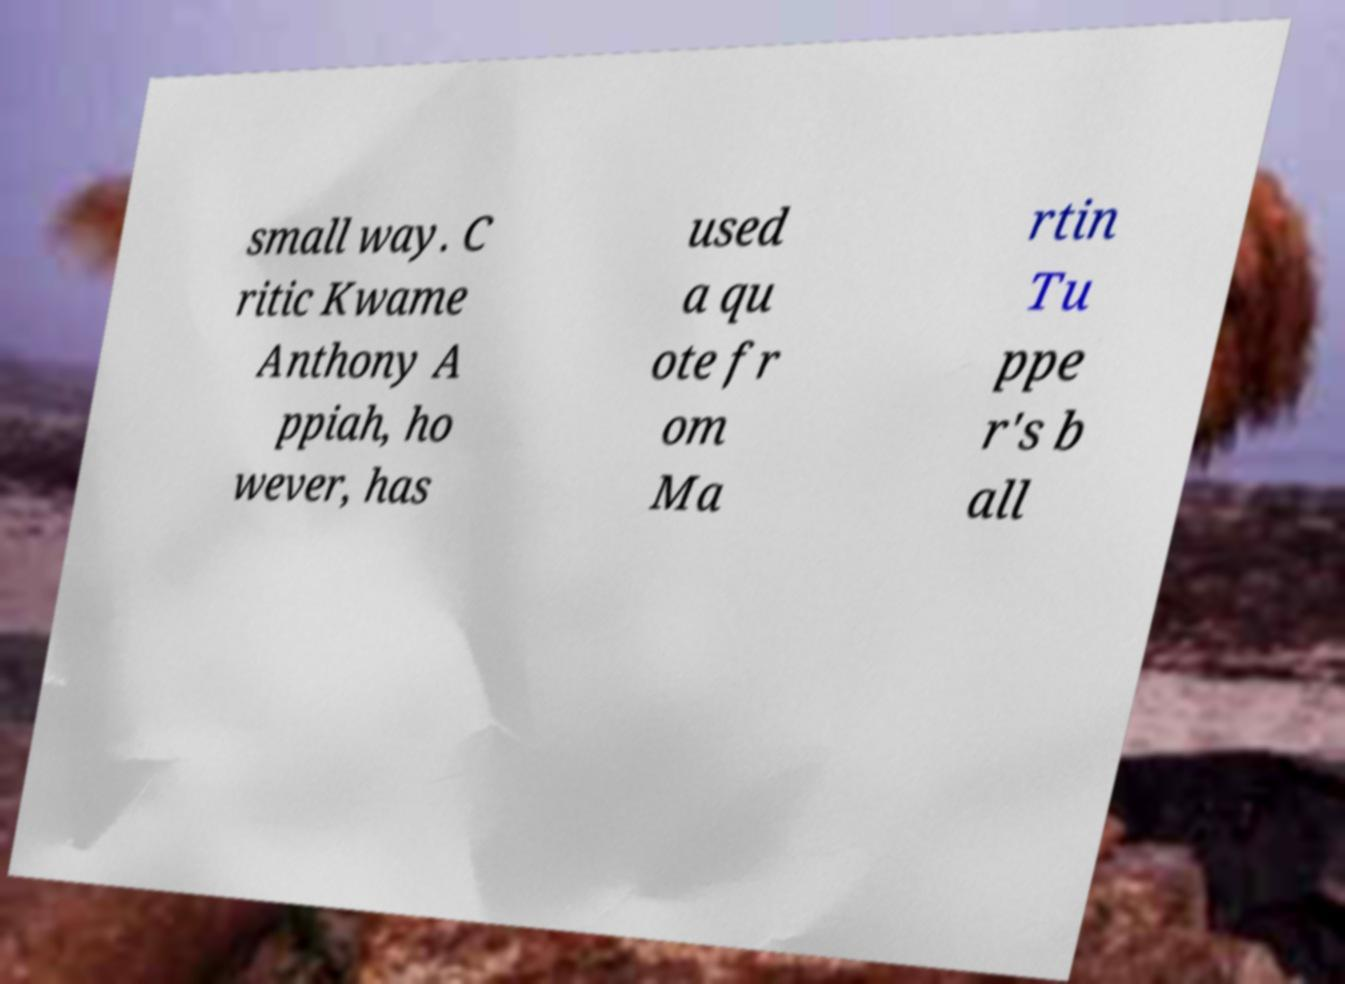What messages or text are displayed in this image? I need them in a readable, typed format. small way. C ritic Kwame Anthony A ppiah, ho wever, has used a qu ote fr om Ma rtin Tu ppe r's b all 